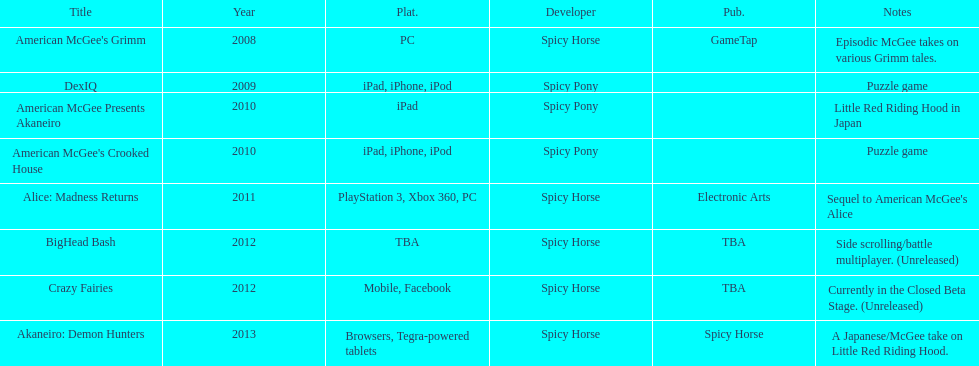What was the number of platforms that supported american mcgee's grimm? 1. 